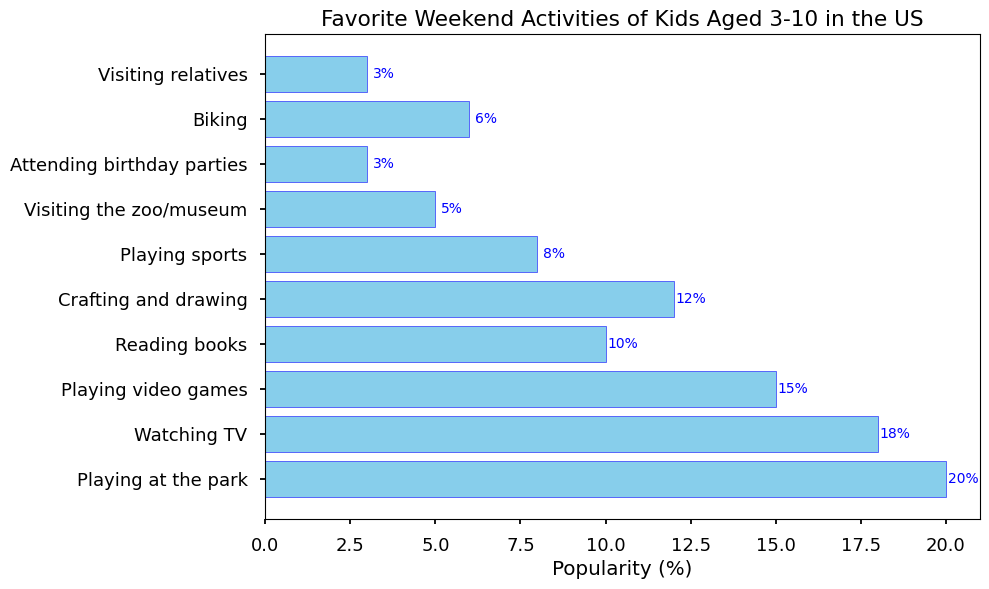What is the most popular weekend activity among kids aged 3-10? From the bar chart, the activity with the longest bar represents the most popular activity. The bar for "Playing at the park" is the longest, indicating it's the most popular.
Answer: Playing at the park Which activity is more popular: Watching TV or Reading books? By comparing the lengths of the bars for "Watching TV" and "Reading books," we see that the bar for "Watching TV" is longer than "Reading books."
Answer: Watching TV What is the total percentage of kids who prefer Playing sports, Visiting the zoo/museum, and Attending birthday parties combined? Sum the popularity percentages of Playing sports (8%), Visiting the zoo/museum (5%), and Attending birthday parties (3%). The total is 8 + 5 + 3 = 16%.
Answer: 16% Are there more kids who like Biking than Visiting relatives? Compare the lengths of the bars for "Biking" and "Visiting relatives." The bar for "Biking" is longer than the bar for "Visiting relatives."
Answer: Yes Which activity has the smallest percentage of kids participating in it? Identify the bar with the smallest height, which corresponds to "Attending birthday parties" and "Visiting relatives," both with 3%.
Answer: Attending birthday parties, Visiting relatives What is the difference in popularity between Playing video games and Crafting and drawing? Subtract the popularity percentage of Crafting and drawing (12%) from that of Playing video games (15%). The difference is 15 - 12 = 3%.
Answer: 3% How many activities have a popularity percentage of 10% or higher? Count the activities with bars that represent 10% or higher: Playing at the park (20%), Watching TV (18%), Playing video games (15%), and Crafting and drawing (12%).
Answer: 4 Which has a higher popularity: Playing sports or Biking and Reading books combined? Compare the sum of the percentages of Biking (6%) and Reading books (10%), which is 6 + 10 = 16%, to the popularity of Playing sports (8%). 16% is higher than 8%.
Answer: Biking and Reading books combined What visual cues indicate the popularity of an activity? The length of the bars represents the popularity percentage. Longer bars indicate higher popularity values. The color consistency (sky blue with blue edges) helps in visual differentiation of the bars.
Answer: Length of bars 